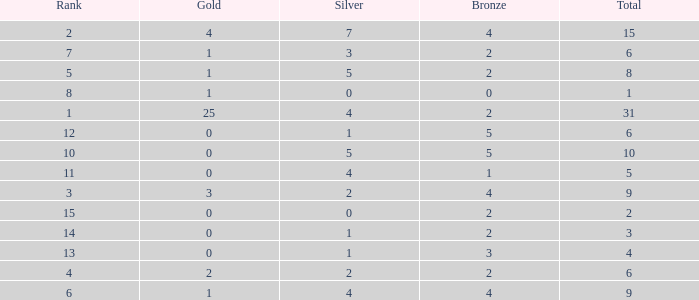What is the highest rank of the medal total less than 15, more than 2 bronzes, 0 gold and 1 silver? 13.0. 